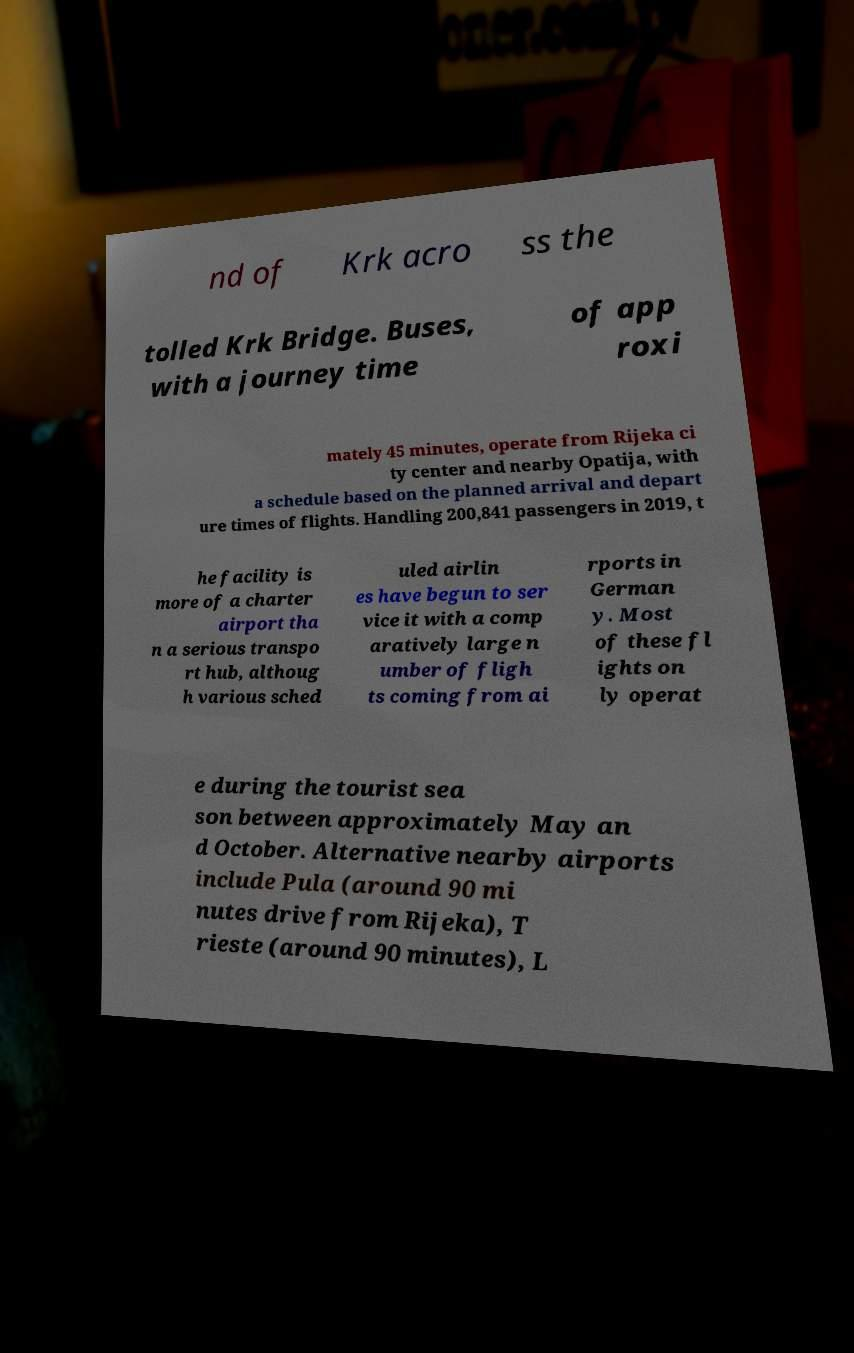Can you read and provide the text displayed in the image?This photo seems to have some interesting text. Can you extract and type it out for me? nd of Krk acro ss the tolled Krk Bridge. Buses, with a journey time of app roxi mately 45 minutes, operate from Rijeka ci ty center and nearby Opatija, with a schedule based on the planned arrival and depart ure times of flights. Handling 200,841 passengers in 2019, t he facility is more of a charter airport tha n a serious transpo rt hub, althoug h various sched uled airlin es have begun to ser vice it with a comp aratively large n umber of fligh ts coming from ai rports in German y. Most of these fl ights on ly operat e during the tourist sea son between approximately May an d October. Alternative nearby airports include Pula (around 90 mi nutes drive from Rijeka), T rieste (around 90 minutes), L 